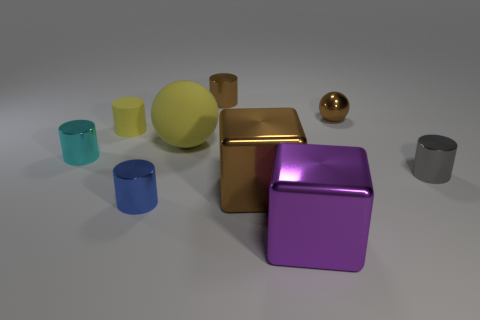Subtract all yellow cylinders. How many cylinders are left? 4 Subtract all yellow cylinders. How many cylinders are left? 4 Subtract all green cylinders. Subtract all blue blocks. How many cylinders are left? 5 Add 1 large purple things. How many objects exist? 10 Subtract all cylinders. How many objects are left? 4 Add 9 yellow matte cylinders. How many yellow matte cylinders exist? 10 Subtract 1 yellow cylinders. How many objects are left? 8 Subtract all tiny blue things. Subtract all large rubber things. How many objects are left? 7 Add 4 shiny blocks. How many shiny blocks are left? 6 